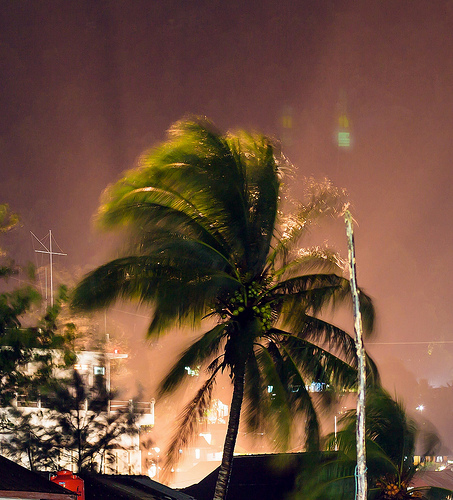<image>
Is the building behind the tree? Yes. From this viewpoint, the building is positioned behind the tree, with the tree partially or fully occluding the building. 